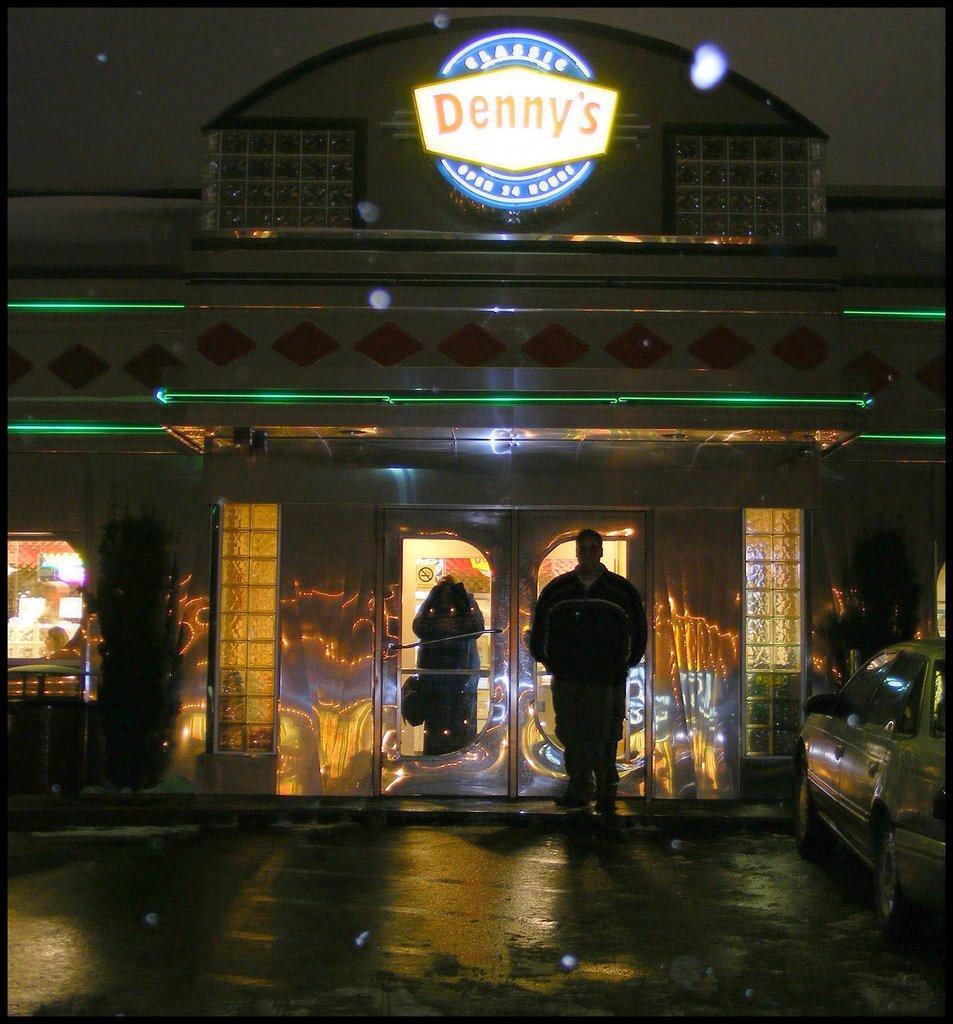Describe this image in one or two sentences. In the middle of the image we can see a man, he is standing in front of the door, beside him we can find few plants and a car, in the background we can see few lights, hoarding and a building. 